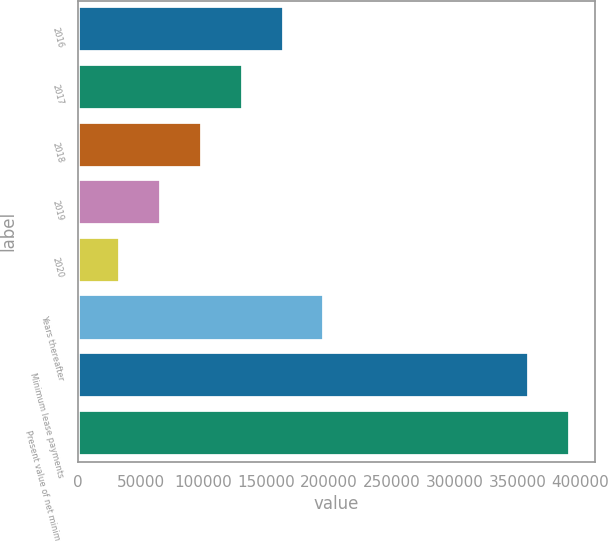<chart> <loc_0><loc_0><loc_500><loc_500><bar_chart><fcel>2016<fcel>2017<fcel>2018<fcel>2019<fcel>2020<fcel>Years thereafter<fcel>Minimum lease payments<fcel>Present value of net minimum<nl><fcel>163730<fcel>131132<fcel>98533.4<fcel>65935.2<fcel>33337<fcel>196328<fcel>359319<fcel>391917<nl></chart> 